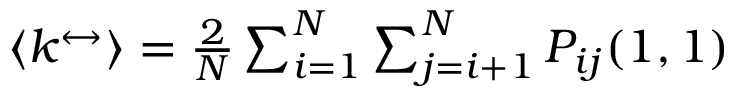<formula> <loc_0><loc_0><loc_500><loc_500>\begin{array} { r } { \left \langle k ^ { \leftrightarrow } \right \rangle = \frac { 2 } { N } \sum _ { i = 1 } ^ { N } \sum _ { j = i + 1 } ^ { N } P _ { i j } ( 1 , 1 ) } \end{array}</formula> 